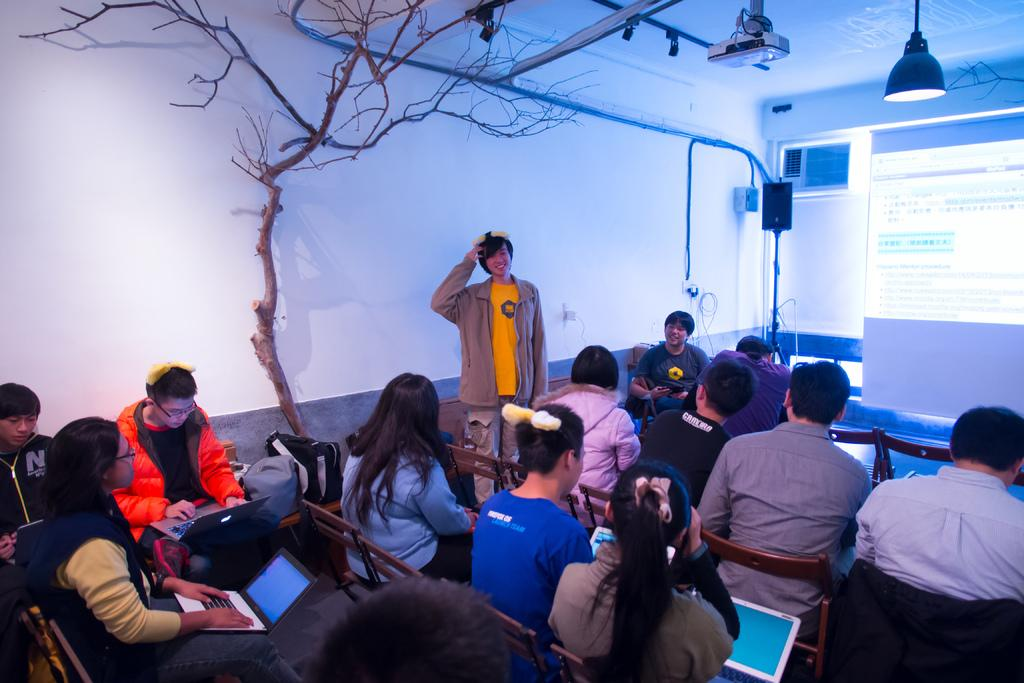What color is the wall in the image? The wall in the image is white. What can be seen in the background of the image? There is a tree in the image. What equipment is present for displaying visuals? There is a projector and a screen in the image. What is the source of light in the image? There is a light in the image. What are the people in the image doing? There is a group of people sitting on chairs in the image, and some of them are holding laptops. What type of mouth can be seen on the tree in the image? There is no mouth present on the tree in the image; it is a natural object and does not have facial features. How many copies of the same document are being distributed by the bike in the image? There is no bike present in the image, and therefore no document distribution is taking place. 